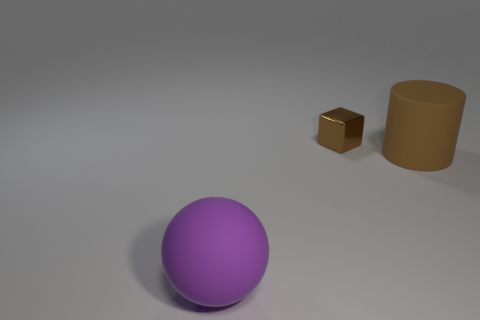Are there any objects of the same color as the rubber sphere?
Your answer should be compact. No. There is a object that is left of the brown object to the left of the matte thing that is right of the purple object; what shape is it?
Your response must be concise. Sphere. There is a brown object that is in front of the cube; what material is it?
Your answer should be compact. Rubber. There is a matte object in front of the large thing that is right of the rubber object left of the brown shiny object; what is its size?
Ensure brevity in your answer.  Large. Is the size of the brown rubber thing the same as the brown block right of the large purple rubber thing?
Keep it short and to the point. No. What color is the big rubber object on the left side of the metal cube?
Provide a succinct answer. Purple. The large rubber object that is the same color as the small metallic object is what shape?
Your response must be concise. Cylinder. What is the shape of the thing left of the metallic object?
Offer a very short reply. Sphere. What number of brown objects are tiny objects or balls?
Offer a terse response. 1. Do the small thing and the ball have the same material?
Your answer should be very brief. No. 